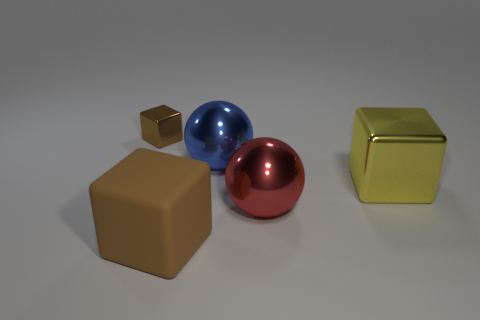Subtract all metallic cubes. How many cubes are left? 1 Add 2 large blue balls. How many objects exist? 7 Subtract all balls. How many objects are left? 3 Subtract all small brown cubes. Subtract all blue shiny objects. How many objects are left? 3 Add 1 big red objects. How many big red objects are left? 2 Add 5 small rubber cylinders. How many small rubber cylinders exist? 5 Subtract 0 brown cylinders. How many objects are left? 5 